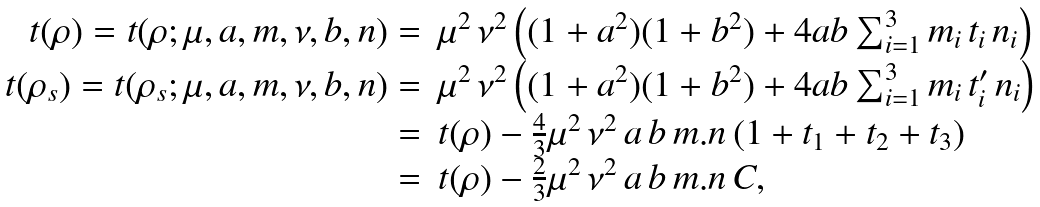Convert formula to latex. <formula><loc_0><loc_0><loc_500><loc_500>\begin{array} { r l } t ( \rho ) = t ( \rho ; \mu , a , { m } , \nu , b , { n } ) = & \mu ^ { 2 } \, \nu ^ { 2 } \left ( ( 1 + a ^ { 2 } ) ( 1 + b ^ { 2 } ) + 4 a b \sum _ { i = 1 } ^ { 3 } m _ { i } \, t _ { i } \, n _ { i } \right ) \\ t ( \rho _ { s } ) = t ( \rho _ { s } ; \mu , a , { m } , \nu , b , { n } ) = & \mu ^ { 2 } \, \nu ^ { 2 } \left ( ( 1 + a ^ { 2 } ) ( 1 + b ^ { 2 } ) + 4 a b \sum _ { i = 1 } ^ { 3 } m _ { i } \, t _ { i } ^ { \prime } \, n _ { i } \right ) \\ = & t ( \rho ) - \frac { 4 } { 3 } \mu ^ { 2 } \, \nu ^ { 2 } \, a \, b \, { m } . { n } \, ( 1 + t _ { 1 } + t _ { 2 } + t _ { 3 } ) \\ = & t ( \rho ) - \frac { 2 } { 3 } \mu ^ { 2 } \, \nu ^ { 2 } \, a \, b \, { m } . { n } \, C , \end{array}</formula> 